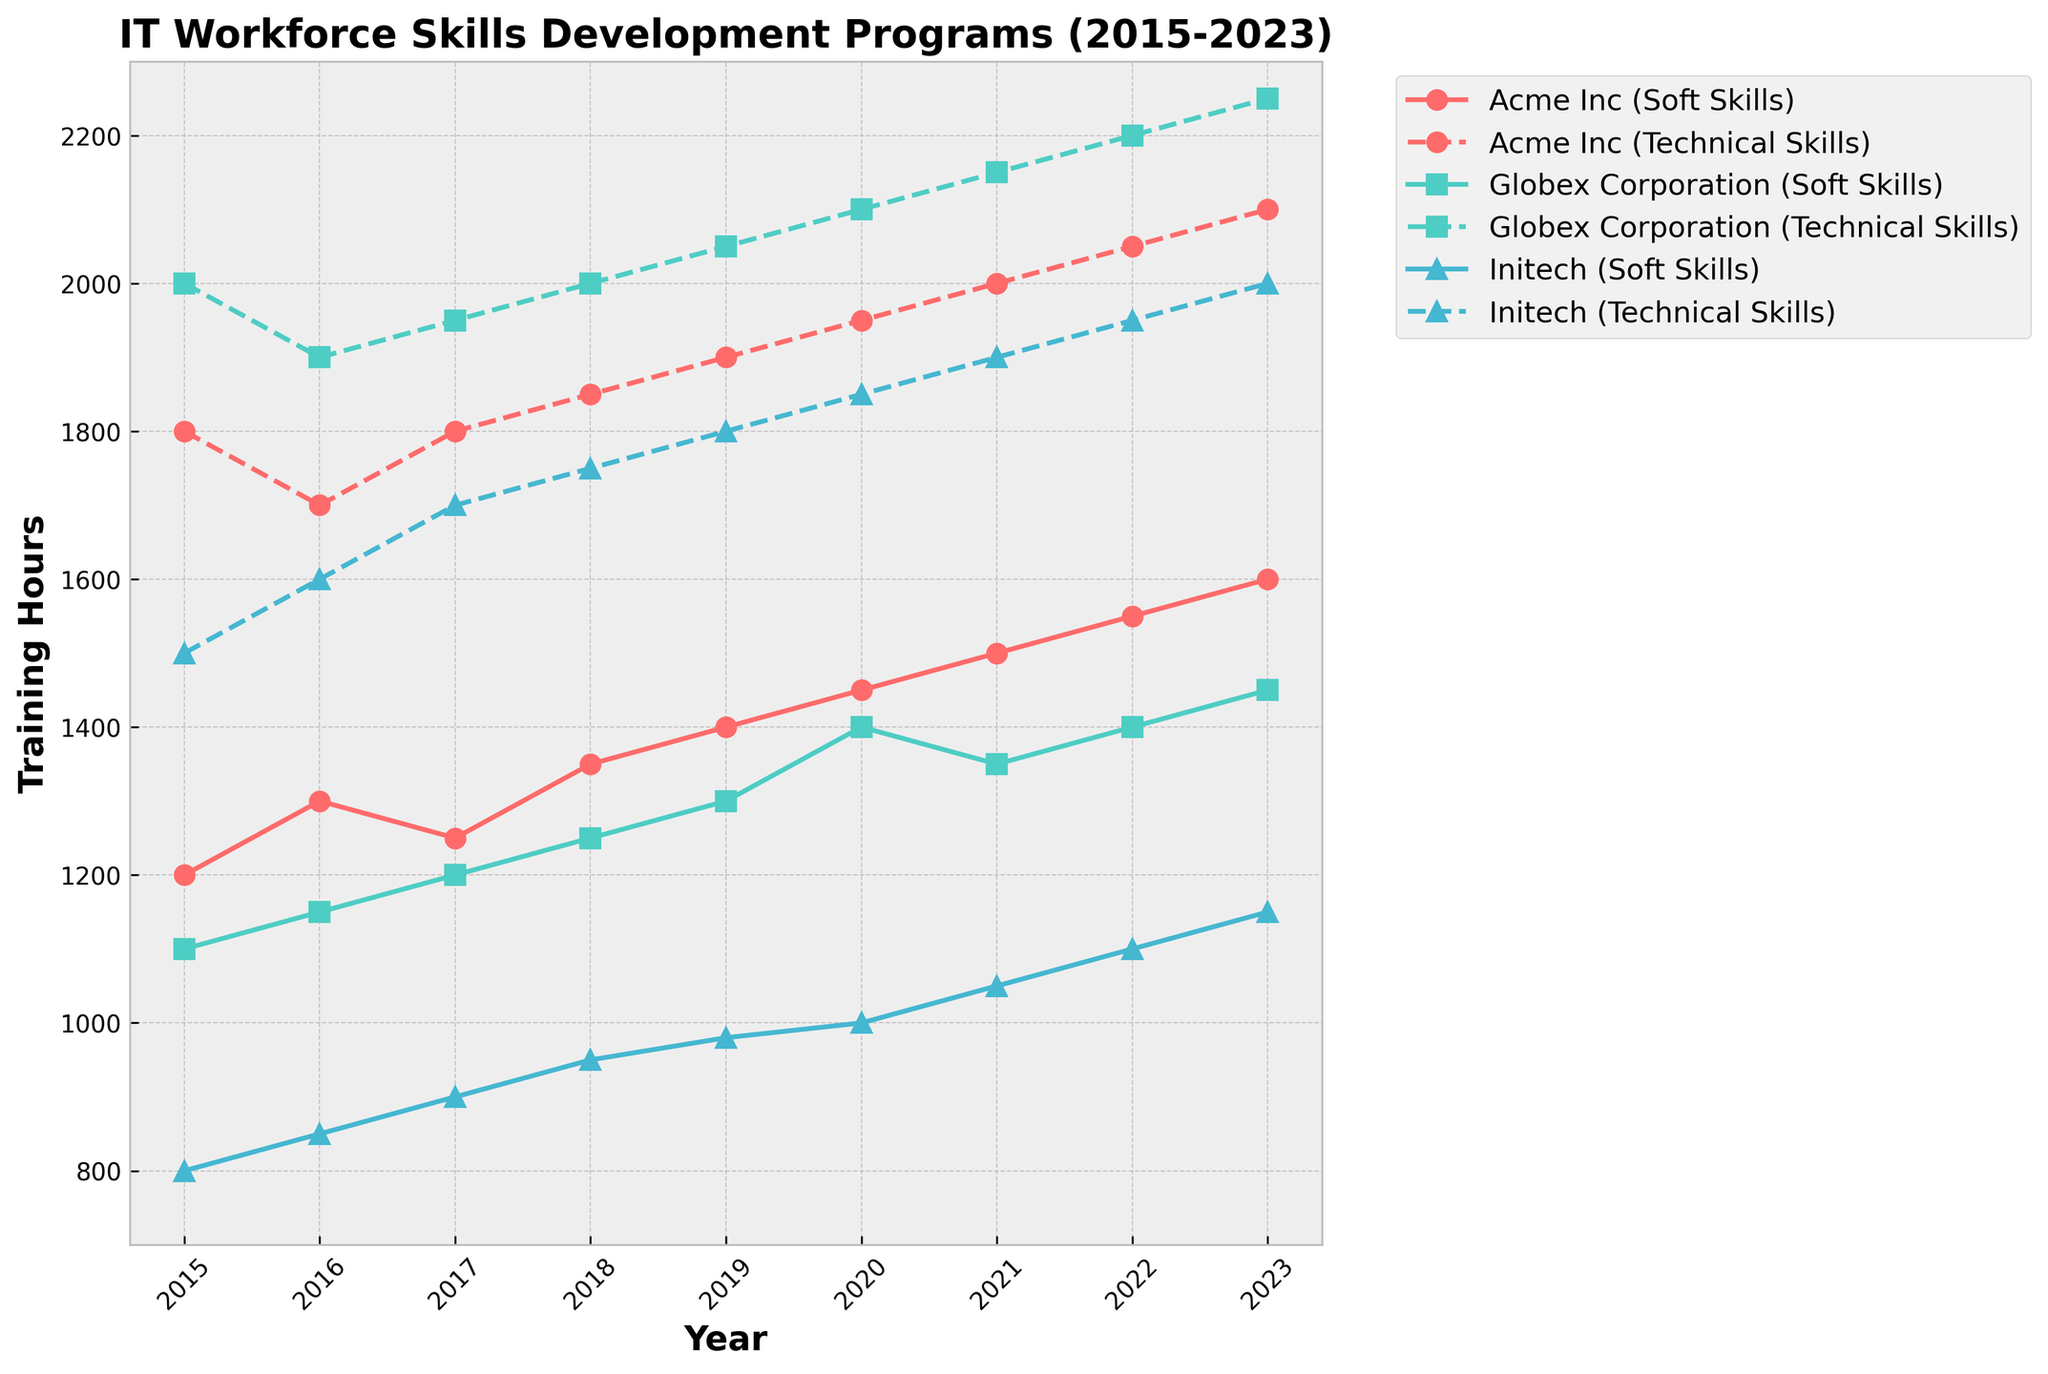What is the title of the plot? The title is located at the top of the figure, stating the main subject of the plot.
Answer: IT Workforce Skills Development Programs (2015-2023) Which company had the highest number of Soft Skills Training Hours in 2023? Locate the data points for 2023 on the plot and identify the highest value among the companies.
Answer: Acme Inc In which year did Globex Corporation have the least Technical Skills Training Hours? Follow the dashed line representing Globex Corporation (Technical Skills) and identify the year with the minimum value.
Answer: 2015 What is the total number of Soft Skills Training Hours for Acme Inc across all years? Sum the training hours represented by the solid line for Acme Inc across all years: 1200 + 1300 + 1250 + 1350 + 1400 + 1450 + 1500 + 1550 + 1600.
Answer: 11600 How did Acme Inc’s Technical Skills Training Hours change from 2015 to 2016? Calculate the difference in Technical Skills Training Hours between 2015 and 2016 for Acme Inc: 1700 - 1800.
Answer: Decreased by 100 Which year shows the highest combined total Training Hours (Soft + Technical) for Initech? For each year, add the Soft Skills and Technical Skills Training Hours and identify the highest total: 2300 (2015), 2450 (2016), 2600 (2017), 2700 (2018), 2780 (2019), 2850 (2020), 2950 (2021), 3050 (2022), 3150 (2023).
Answer: 2023 Which company had the smallest growth in Technical Skills Training Hours from 2015 to 2023? Calculate the difference ((2023 - 2015) values) for each company and identify the smallest: Acme Inc (2100 - 1800), Globex Corporation (2250 - 2000), Initech (2000 - 1500).
Answer: Acme Inc Compare the Soft Skills Training Hours between Acme Inc and Globex Corporation in 2019. Who had more? Look at the solid lines for Acme Inc and Globex Corporation in 2019 and compare the values.
Answer: Acme Inc What trend is observed in the Technical Skills Training Hours for Initech from 2015 to 2023? Follow the dashed line representing Initech’s Technical Skills Training Hours and describe the overall pattern.
Answer: Increasing trend Did any company invest more in Soft Skills Training than Technical Skills Training in 2023? For each company in 2023, compare the values of Soft Skills Training (solid line) and Technical Skills Training (dashed line).
Answer: No 